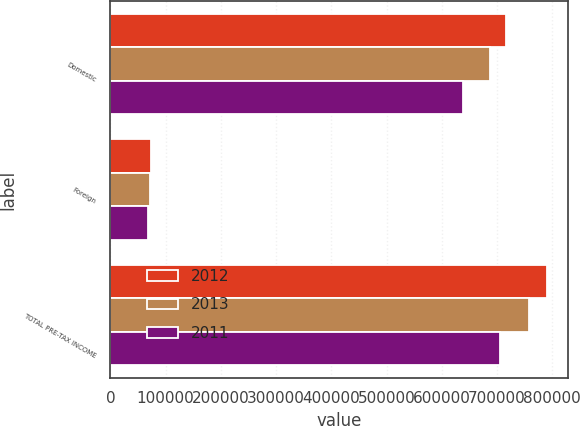<chart> <loc_0><loc_0><loc_500><loc_500><stacked_bar_chart><ecel><fcel>Domestic<fcel>Foreign<fcel>TOTAL PRE-TAX INCOME<nl><fcel>2012<fcel>716172<fcel>73527<fcel>789699<nl><fcel>2013<fcel>686571<fcel>71180<fcel>757751<nl><fcel>2011<fcel>637708<fcel>68419<fcel>706127<nl></chart> 